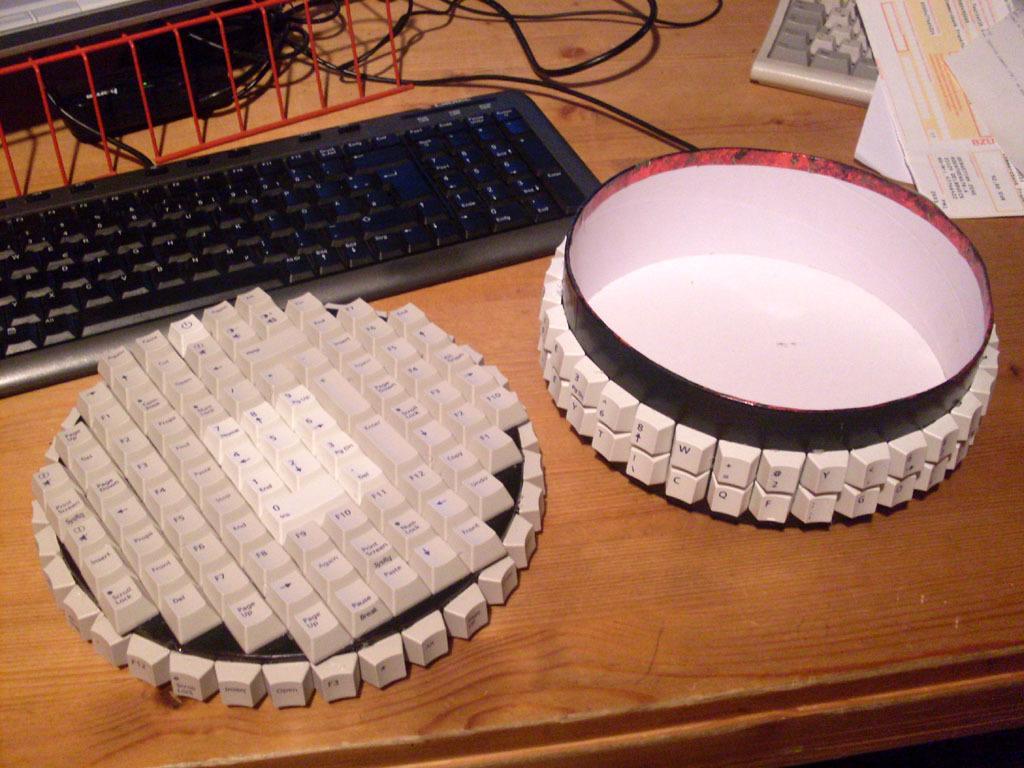How would you summarize this image in a sentence or two? Bottom of the image there is a table, on the table there is a keyboard and different types of keyboards and papers and wires. 